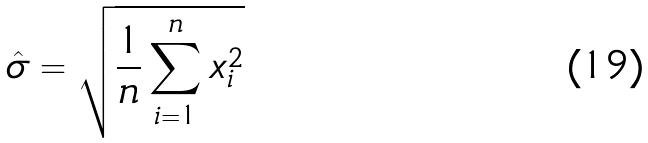Convert formula to latex. <formula><loc_0><loc_0><loc_500><loc_500>\hat { \sigma } = \sqrt { \frac { 1 } { n } \sum _ { i = 1 } ^ { n } x _ { i } ^ { 2 } }</formula> 